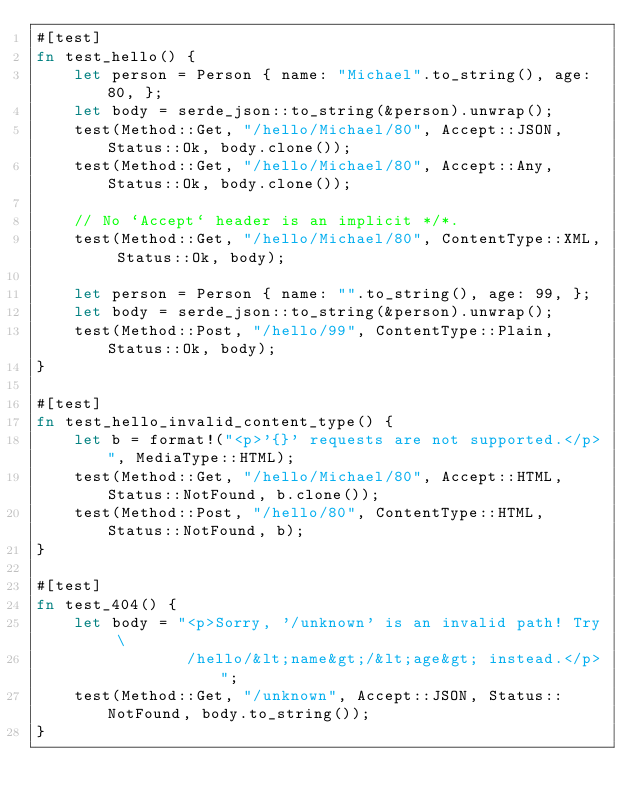Convert code to text. <code><loc_0><loc_0><loc_500><loc_500><_Rust_>#[test]
fn test_hello() {
    let person = Person { name: "Michael".to_string(), age: 80, };
    let body = serde_json::to_string(&person).unwrap();
    test(Method::Get, "/hello/Michael/80", Accept::JSON, Status::Ok, body.clone());
    test(Method::Get, "/hello/Michael/80", Accept::Any, Status::Ok, body.clone());

    // No `Accept` header is an implicit */*.
    test(Method::Get, "/hello/Michael/80", ContentType::XML, Status::Ok, body);

    let person = Person { name: "".to_string(), age: 99, };
    let body = serde_json::to_string(&person).unwrap();
    test(Method::Post, "/hello/99", ContentType::Plain, Status::Ok, body);
}

#[test]
fn test_hello_invalid_content_type() {
    let b = format!("<p>'{}' requests are not supported.</p>", MediaType::HTML);
    test(Method::Get, "/hello/Michael/80", Accept::HTML, Status::NotFound, b.clone());
    test(Method::Post, "/hello/80", ContentType::HTML, Status::NotFound, b);
}

#[test]
fn test_404() {
    let body = "<p>Sorry, '/unknown' is an invalid path! Try \
                /hello/&lt;name&gt;/&lt;age&gt; instead.</p>";
    test(Method::Get, "/unknown", Accept::JSON, Status::NotFound, body.to_string());
}
</code> 